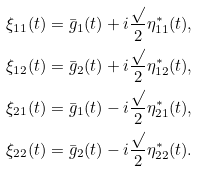Convert formula to latex. <formula><loc_0><loc_0><loc_500><loc_500>\xi _ { 1 1 } ( t ) & = \bar { g } _ { 1 } ( t ) + i \frac { \sqrt { } } { 2 } \eta ^ { * } _ { 1 1 } ( t ) , \\ \xi _ { 1 2 } ( t ) & = \bar { g } _ { 2 } ( t ) + i \frac { \sqrt { } } { 2 } \eta ^ { * } _ { 1 2 } ( t ) , \\ \xi _ { 2 1 } ( t ) & = \bar { g } _ { 1 } ( t ) - i \frac { \sqrt { } } { 2 } \eta ^ { * } _ { 2 1 } ( t ) , \\ \xi _ { 2 2 } ( t ) & = \bar { g } _ { 2 } ( t ) - i \frac { \sqrt { } } { 2 } \eta ^ { * } _ { 2 2 } ( t ) .</formula> 